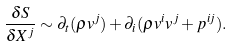Convert formula to latex. <formula><loc_0><loc_0><loc_500><loc_500>\frac { \delta S } { \delta X ^ { j } } \sim \partial _ { t } ( \rho v ^ { j } ) + \partial _ { i } ( \rho v ^ { i } v ^ { j } + p ^ { i j } ) .</formula> 